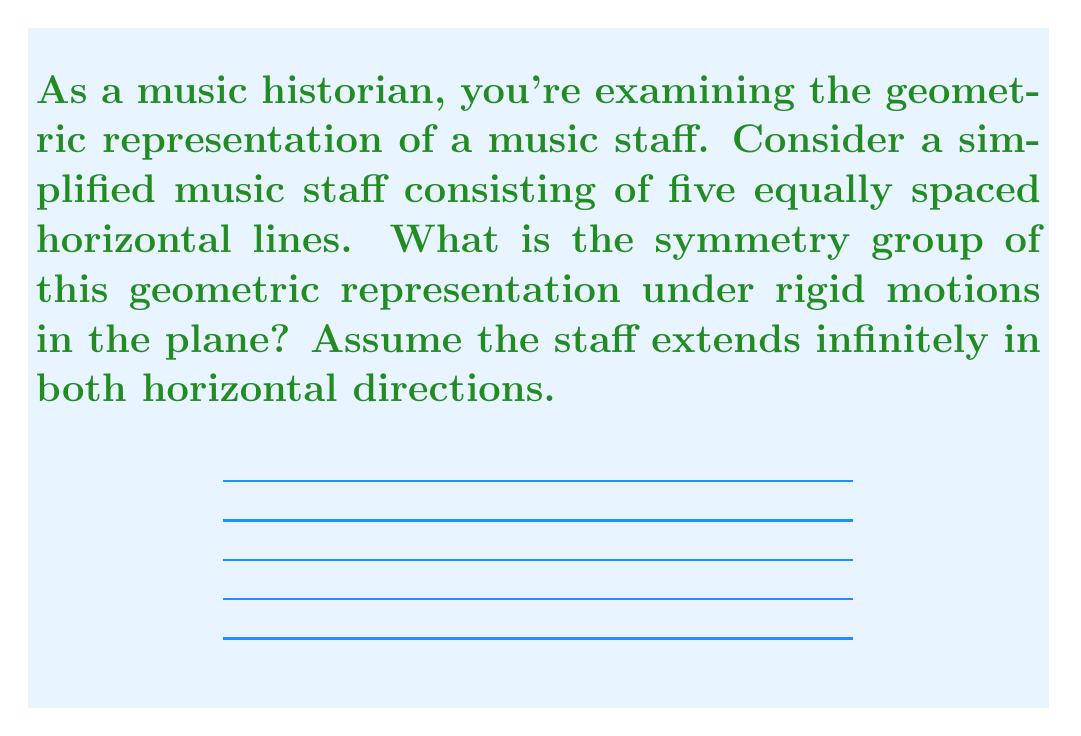Provide a solution to this math problem. Let's approach this step-by-step:

1) First, we need to identify the symmetries of this geometric representation:

   a) Horizontal translation: The staff is invariant under any horizontal translation.
   b) Vertical reflection: The staff is symmetric about any horizontal line midway between two staff lines or along a staff line.
   c) 180° rotation: The staff remains unchanged when rotated 180° about any point.

2) These symmetries form a group. Let's identify the group structure:

   a) Translations form a subgroup isomorphic to $\mathbb{R}$, the real numbers under addition.
   b) Vertical reflections and 180° rotations, combined with translations, form a group isomorphic to $\mathbb{Z}_2 \ltimes \mathbb{R}$.

3) The symmetry group is thus isomorphic to $\mathbb{Z}_2 \ltimes \mathbb{R}$, where $\mathbb{Z}_2$ acts on $\mathbb{R}$ by negation.

4) This group is known as the frieze group $p11g$ in crystallographic notation, or $\text{F}^r_2$ in Conway's orbifold notation.

5) In terms of Lie groups, this is the one-dimensional Euclidean group $E(1)$, which is the semidirect product of $\mathbb{R}$ with $\mathbb{Z}_2$.

Therefore, the symmetry group of the music staff under rigid motions is isomorphic to the one-dimensional Euclidean group $E(1)$.
Answer: $E(1) \cong \mathbb{Z}_2 \ltimes \mathbb{R}$ 